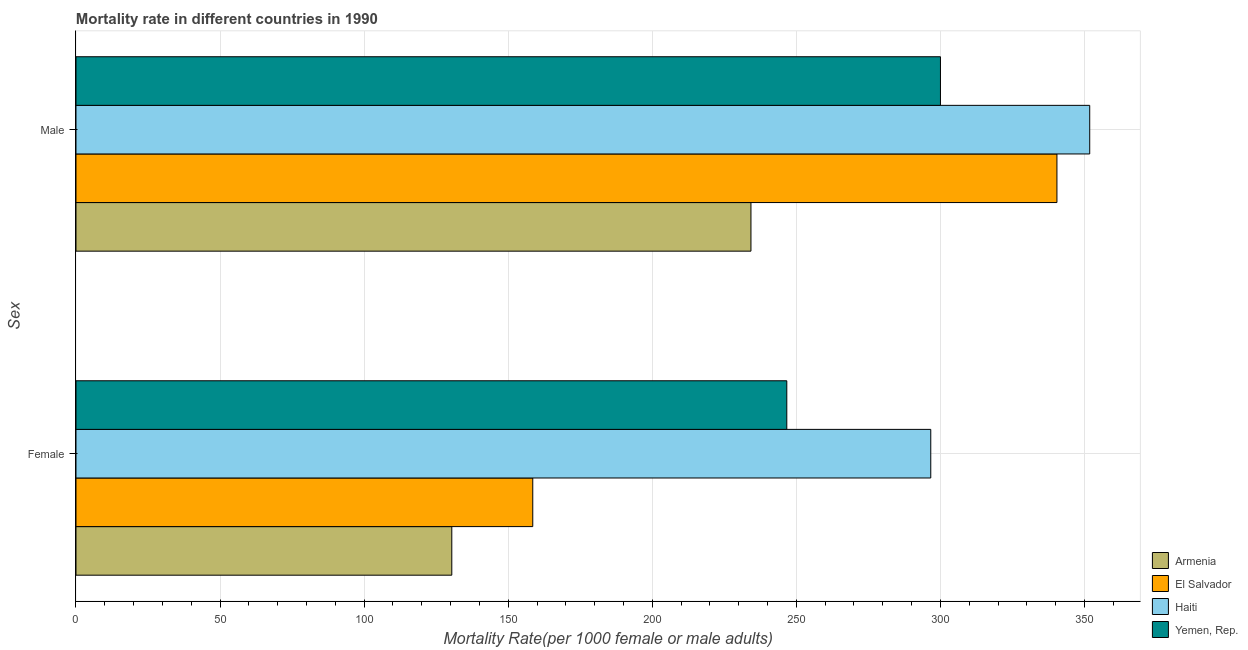How many groups of bars are there?
Provide a succinct answer. 2. Are the number of bars on each tick of the Y-axis equal?
Ensure brevity in your answer.  Yes. How many bars are there on the 2nd tick from the bottom?
Make the answer very short. 4. What is the male mortality rate in Haiti?
Give a very brief answer. 351.82. Across all countries, what is the maximum female mortality rate?
Make the answer very short. 296.66. Across all countries, what is the minimum female mortality rate?
Offer a very short reply. 130.43. In which country was the male mortality rate maximum?
Offer a very short reply. Haiti. In which country was the female mortality rate minimum?
Make the answer very short. Armenia. What is the total female mortality rate in the graph?
Your answer should be very brief. 832.3. What is the difference between the female mortality rate in Haiti and that in Armenia?
Keep it short and to the point. 166.23. What is the difference between the male mortality rate in Armenia and the female mortality rate in Haiti?
Make the answer very short. -62.41. What is the average male mortality rate per country?
Your answer should be very brief. 306.63. What is the difference between the male mortality rate and female mortality rate in Yemen, Rep.?
Keep it short and to the point. 53.33. What is the ratio of the male mortality rate in Yemen, Rep. to that in El Salvador?
Your answer should be compact. 0.88. What does the 2nd bar from the top in Female represents?
Offer a very short reply. Haiti. What does the 3rd bar from the bottom in Male represents?
Your response must be concise. Haiti. How many bars are there?
Give a very brief answer. 8. What is the difference between two consecutive major ticks on the X-axis?
Make the answer very short. 50. Are the values on the major ticks of X-axis written in scientific E-notation?
Ensure brevity in your answer.  No. Does the graph contain grids?
Give a very brief answer. Yes. How are the legend labels stacked?
Your answer should be very brief. Vertical. What is the title of the graph?
Provide a short and direct response. Mortality rate in different countries in 1990. What is the label or title of the X-axis?
Provide a short and direct response. Mortality Rate(per 1000 female or male adults). What is the label or title of the Y-axis?
Provide a succinct answer. Sex. What is the Mortality Rate(per 1000 female or male adults) of Armenia in Female?
Provide a succinct answer. 130.43. What is the Mortality Rate(per 1000 female or male adults) of El Salvador in Female?
Provide a succinct answer. 158.53. What is the Mortality Rate(per 1000 female or male adults) in Haiti in Female?
Ensure brevity in your answer.  296.66. What is the Mortality Rate(per 1000 female or male adults) in Yemen, Rep. in Female?
Your response must be concise. 246.69. What is the Mortality Rate(per 1000 female or male adults) of Armenia in Male?
Offer a terse response. 234.25. What is the Mortality Rate(per 1000 female or male adults) of El Salvador in Male?
Provide a short and direct response. 340.45. What is the Mortality Rate(per 1000 female or male adults) of Haiti in Male?
Provide a short and direct response. 351.82. What is the Mortality Rate(per 1000 female or male adults) in Yemen, Rep. in Male?
Offer a very short reply. 300.02. Across all Sex, what is the maximum Mortality Rate(per 1000 female or male adults) in Armenia?
Your response must be concise. 234.25. Across all Sex, what is the maximum Mortality Rate(per 1000 female or male adults) of El Salvador?
Your answer should be very brief. 340.45. Across all Sex, what is the maximum Mortality Rate(per 1000 female or male adults) of Haiti?
Your response must be concise. 351.82. Across all Sex, what is the maximum Mortality Rate(per 1000 female or male adults) of Yemen, Rep.?
Provide a succinct answer. 300.02. Across all Sex, what is the minimum Mortality Rate(per 1000 female or male adults) of Armenia?
Your answer should be compact. 130.43. Across all Sex, what is the minimum Mortality Rate(per 1000 female or male adults) in El Salvador?
Offer a very short reply. 158.53. Across all Sex, what is the minimum Mortality Rate(per 1000 female or male adults) in Haiti?
Provide a short and direct response. 296.66. Across all Sex, what is the minimum Mortality Rate(per 1000 female or male adults) in Yemen, Rep.?
Your response must be concise. 246.69. What is the total Mortality Rate(per 1000 female or male adults) of Armenia in the graph?
Your response must be concise. 364.68. What is the total Mortality Rate(per 1000 female or male adults) of El Salvador in the graph?
Your answer should be very brief. 498.97. What is the total Mortality Rate(per 1000 female or male adults) in Haiti in the graph?
Your answer should be compact. 648.48. What is the total Mortality Rate(per 1000 female or male adults) in Yemen, Rep. in the graph?
Give a very brief answer. 546.71. What is the difference between the Mortality Rate(per 1000 female or male adults) in Armenia in Female and that in Male?
Give a very brief answer. -103.83. What is the difference between the Mortality Rate(per 1000 female or male adults) of El Salvador in Female and that in Male?
Provide a short and direct response. -181.92. What is the difference between the Mortality Rate(per 1000 female or male adults) in Haiti in Female and that in Male?
Offer a terse response. -55.16. What is the difference between the Mortality Rate(per 1000 female or male adults) of Yemen, Rep. in Female and that in Male?
Keep it short and to the point. -53.33. What is the difference between the Mortality Rate(per 1000 female or male adults) in Armenia in Female and the Mortality Rate(per 1000 female or male adults) in El Salvador in Male?
Provide a short and direct response. -210.02. What is the difference between the Mortality Rate(per 1000 female or male adults) in Armenia in Female and the Mortality Rate(per 1000 female or male adults) in Haiti in Male?
Ensure brevity in your answer.  -221.4. What is the difference between the Mortality Rate(per 1000 female or male adults) of Armenia in Female and the Mortality Rate(per 1000 female or male adults) of Yemen, Rep. in Male?
Provide a short and direct response. -169.59. What is the difference between the Mortality Rate(per 1000 female or male adults) in El Salvador in Female and the Mortality Rate(per 1000 female or male adults) in Haiti in Male?
Provide a short and direct response. -193.29. What is the difference between the Mortality Rate(per 1000 female or male adults) in El Salvador in Female and the Mortality Rate(per 1000 female or male adults) in Yemen, Rep. in Male?
Make the answer very short. -141.49. What is the difference between the Mortality Rate(per 1000 female or male adults) in Haiti in Female and the Mortality Rate(per 1000 female or male adults) in Yemen, Rep. in Male?
Your answer should be very brief. -3.36. What is the average Mortality Rate(per 1000 female or male adults) of Armenia per Sex?
Offer a terse response. 182.34. What is the average Mortality Rate(per 1000 female or male adults) in El Salvador per Sex?
Offer a terse response. 249.49. What is the average Mortality Rate(per 1000 female or male adults) of Haiti per Sex?
Give a very brief answer. 324.24. What is the average Mortality Rate(per 1000 female or male adults) of Yemen, Rep. per Sex?
Make the answer very short. 273.35. What is the difference between the Mortality Rate(per 1000 female or male adults) of Armenia and Mortality Rate(per 1000 female or male adults) of El Salvador in Female?
Keep it short and to the point. -28.1. What is the difference between the Mortality Rate(per 1000 female or male adults) in Armenia and Mortality Rate(per 1000 female or male adults) in Haiti in Female?
Offer a terse response. -166.23. What is the difference between the Mortality Rate(per 1000 female or male adults) of Armenia and Mortality Rate(per 1000 female or male adults) of Yemen, Rep. in Female?
Your response must be concise. -116.27. What is the difference between the Mortality Rate(per 1000 female or male adults) of El Salvador and Mortality Rate(per 1000 female or male adults) of Haiti in Female?
Your answer should be very brief. -138.13. What is the difference between the Mortality Rate(per 1000 female or male adults) in El Salvador and Mortality Rate(per 1000 female or male adults) in Yemen, Rep. in Female?
Provide a short and direct response. -88.16. What is the difference between the Mortality Rate(per 1000 female or male adults) in Haiti and Mortality Rate(per 1000 female or male adults) in Yemen, Rep. in Female?
Make the answer very short. 49.97. What is the difference between the Mortality Rate(per 1000 female or male adults) in Armenia and Mortality Rate(per 1000 female or male adults) in El Salvador in Male?
Offer a terse response. -106.19. What is the difference between the Mortality Rate(per 1000 female or male adults) of Armenia and Mortality Rate(per 1000 female or male adults) of Haiti in Male?
Provide a succinct answer. -117.57. What is the difference between the Mortality Rate(per 1000 female or male adults) of Armenia and Mortality Rate(per 1000 female or male adults) of Yemen, Rep. in Male?
Ensure brevity in your answer.  -65.77. What is the difference between the Mortality Rate(per 1000 female or male adults) in El Salvador and Mortality Rate(per 1000 female or male adults) in Haiti in Male?
Provide a short and direct response. -11.38. What is the difference between the Mortality Rate(per 1000 female or male adults) of El Salvador and Mortality Rate(per 1000 female or male adults) of Yemen, Rep. in Male?
Your answer should be very brief. 40.43. What is the difference between the Mortality Rate(per 1000 female or male adults) in Haiti and Mortality Rate(per 1000 female or male adults) in Yemen, Rep. in Male?
Provide a succinct answer. 51.8. What is the ratio of the Mortality Rate(per 1000 female or male adults) in Armenia in Female to that in Male?
Offer a very short reply. 0.56. What is the ratio of the Mortality Rate(per 1000 female or male adults) of El Salvador in Female to that in Male?
Ensure brevity in your answer.  0.47. What is the ratio of the Mortality Rate(per 1000 female or male adults) of Haiti in Female to that in Male?
Provide a succinct answer. 0.84. What is the ratio of the Mortality Rate(per 1000 female or male adults) of Yemen, Rep. in Female to that in Male?
Offer a very short reply. 0.82. What is the difference between the highest and the second highest Mortality Rate(per 1000 female or male adults) in Armenia?
Provide a succinct answer. 103.83. What is the difference between the highest and the second highest Mortality Rate(per 1000 female or male adults) of El Salvador?
Provide a succinct answer. 181.92. What is the difference between the highest and the second highest Mortality Rate(per 1000 female or male adults) of Haiti?
Offer a very short reply. 55.16. What is the difference between the highest and the second highest Mortality Rate(per 1000 female or male adults) of Yemen, Rep.?
Give a very brief answer. 53.33. What is the difference between the highest and the lowest Mortality Rate(per 1000 female or male adults) in Armenia?
Offer a very short reply. 103.83. What is the difference between the highest and the lowest Mortality Rate(per 1000 female or male adults) in El Salvador?
Offer a very short reply. 181.92. What is the difference between the highest and the lowest Mortality Rate(per 1000 female or male adults) of Haiti?
Offer a very short reply. 55.16. What is the difference between the highest and the lowest Mortality Rate(per 1000 female or male adults) in Yemen, Rep.?
Provide a short and direct response. 53.33. 